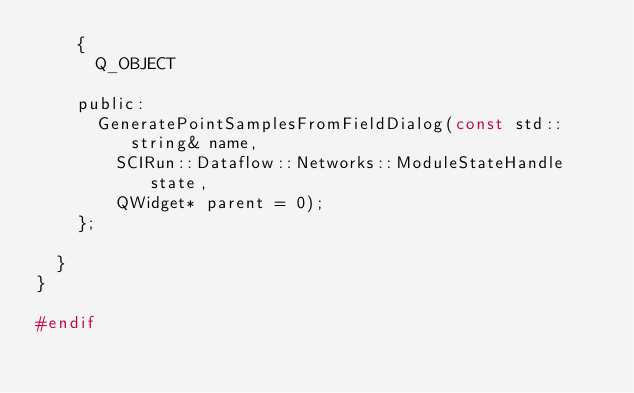<code> <loc_0><loc_0><loc_500><loc_500><_C_>    {
      Q_OBJECT

    public:
      GeneratePointSamplesFromFieldDialog(const std::string& name,
        SCIRun::Dataflow::Networks::ModuleStateHandle state,
        QWidget* parent = 0);
    };

  }
}

#endif
</code> 